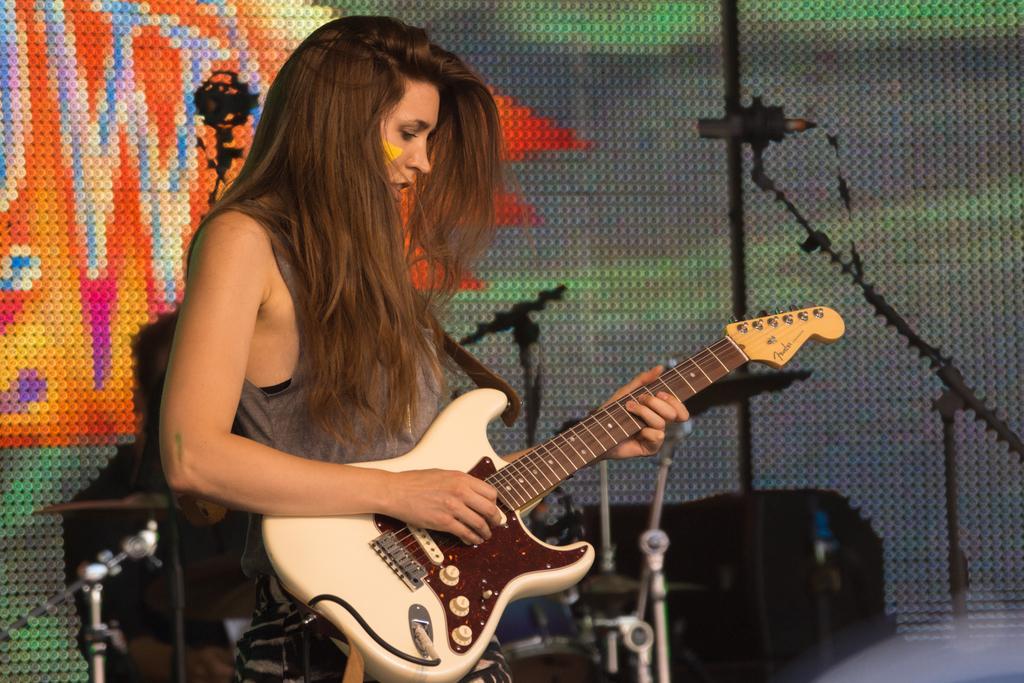Please provide a concise description of this image. In this picture we observe a lady holding a guitar and playing. It seems like a musical concert. In the background there are LED lights mounted to the wall and a pair of cameras focusing on her. Black boxes are kept in the background which might be the musical sound systems. 